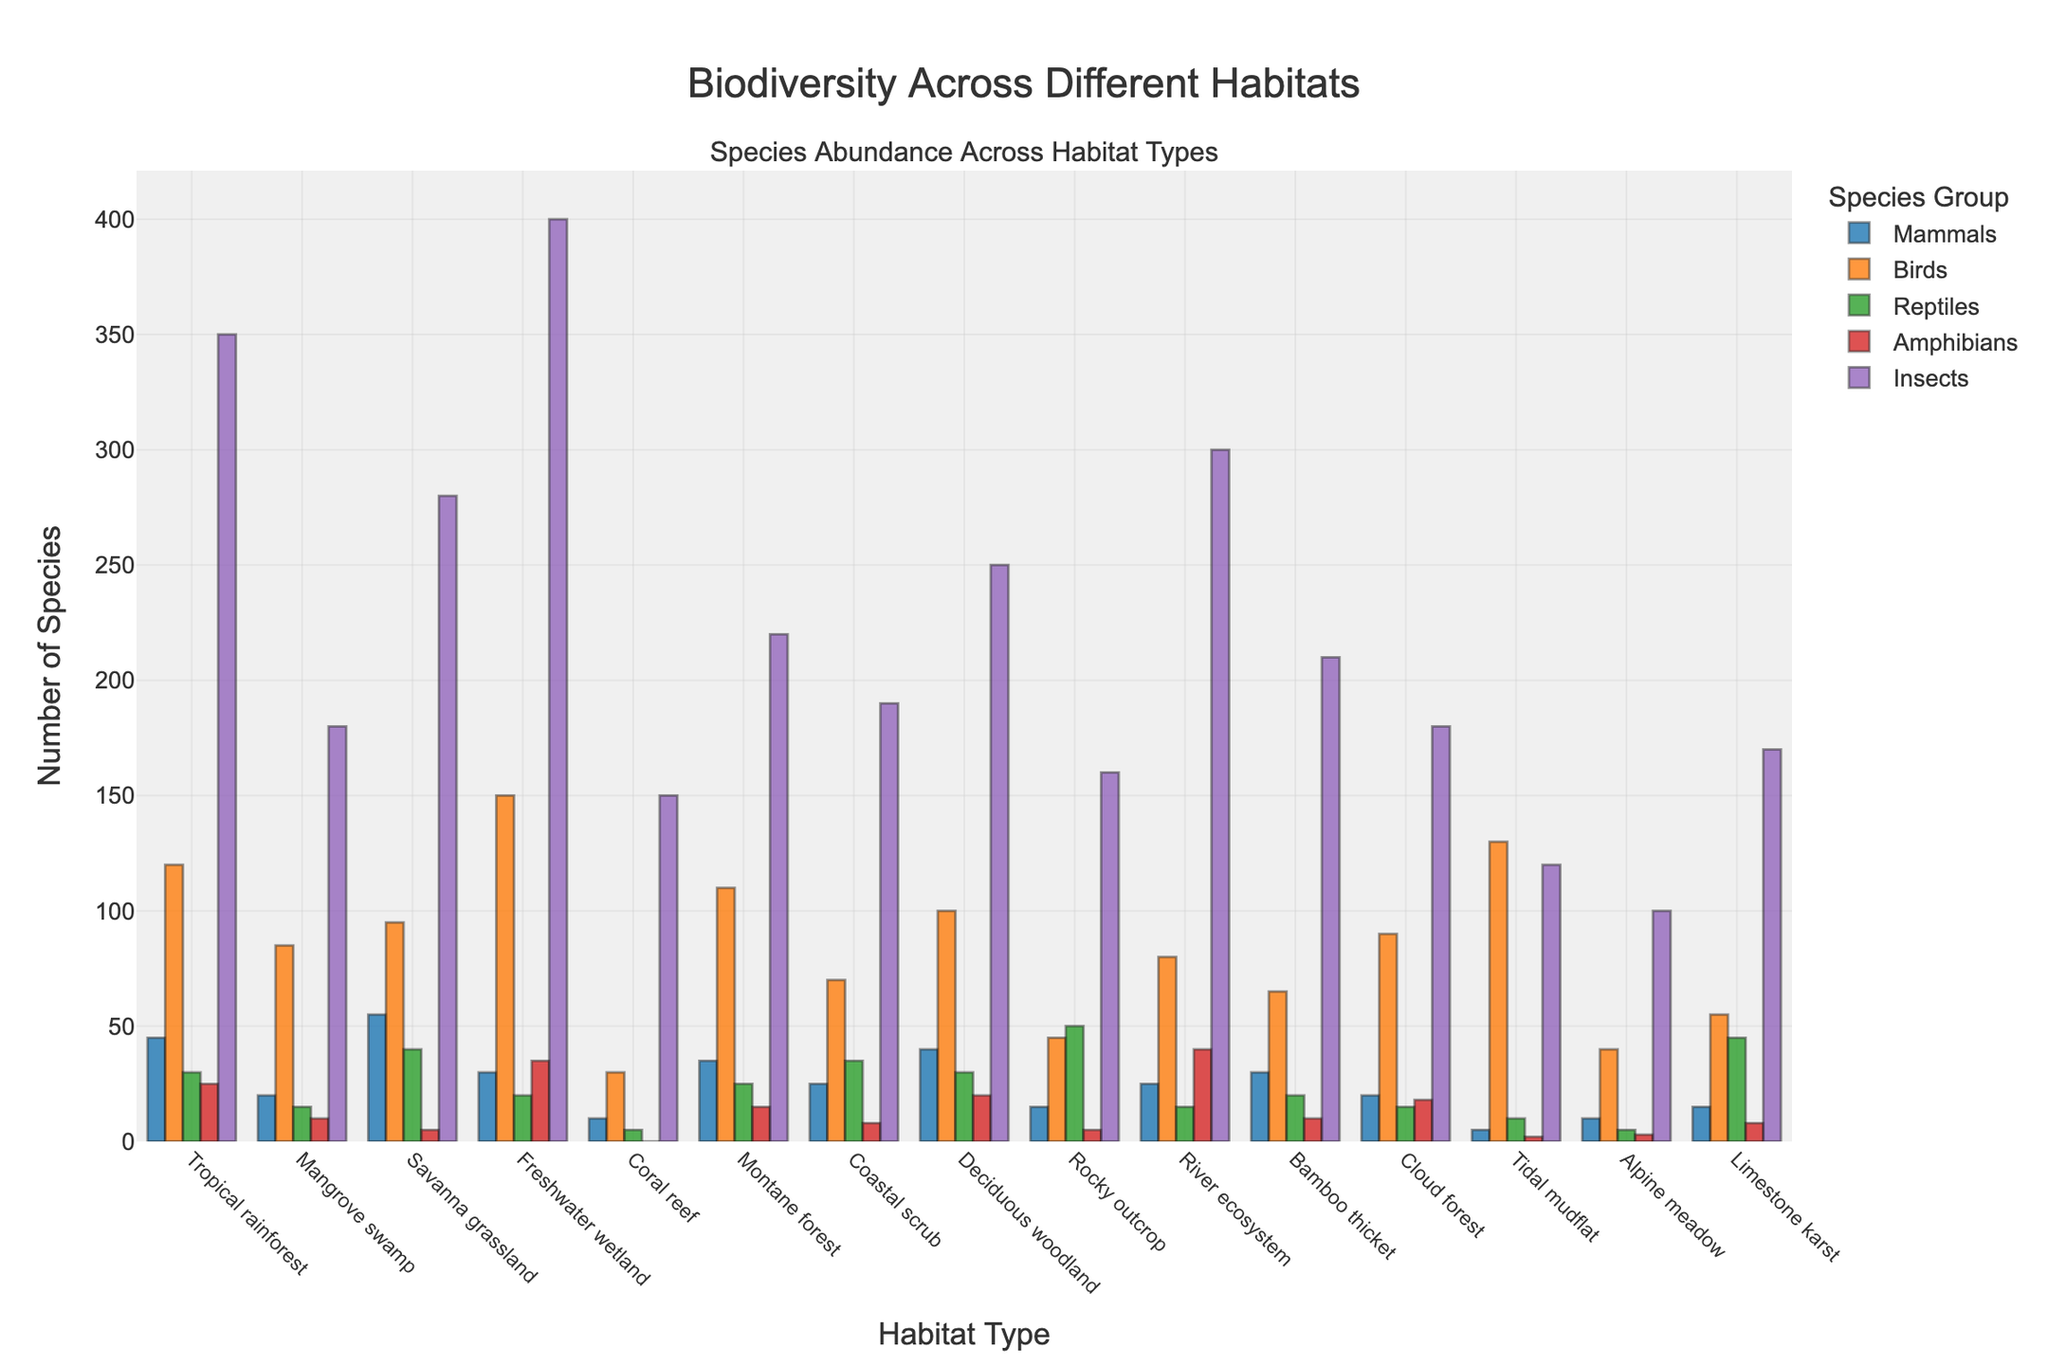Which habitat has the highest number of birds? To answer this question, scan the bar heights for birds across all habitats in the figure. The tallest bar corresponds to the habitat with the greatest number of birds, which is "Freshwater wetland" with 150 birds.
Answer: Freshwater wetland Which habitat has the least number of reptiles? Look at the bars representing reptiles in each habitat and identify the shortest. The shortest bar is associated with the "Alpine meadow" habitat, which has only 5 reptiles.
Answer: Alpine meadow How many mammals and birds are there in the Tropical rainforest combined? Find the bars representing mammals (45) and birds (120) in the "Tropical rainforest" habitat. Add these two values together: 45 + 120 = 165.
Answer: 165 Which habitat has a higher number of amphibians, Montane forest or Coastal scrub? Compare the heights of the bars representing amphibians in "Montane forest" (15) and "Coastal scrub" (8). Montane forest has a higher number.
Answer: Montane forest What is the total number of species recorded in the River ecosystem? For the "River ecosystem" habitat, sum the species counts across all groups: 25 (mammals) + 80 (birds) + 15 (reptiles) + 40 (amphibians) + 300 (insects) = 460.
Answer: 460 Which two habitats have the same number of amphibians? Visually inspect the bars for amphibians across all habitats. "Montane forest" and "Limestone karst" both have 15 amphibians.
Answer: Montane forest and Limestone karst What is the average number of insects across all habitats? Sum the insect counts for all habitats and divide by the number of habitats. Total insects count: 350 + 180 + 280 + 400 + 150 + 220 + 190 + 250 + 160 + 300 + 210 + 180 + 120 + 100 + 170 = 3660. Divide by the number of habitats (15): 3660 / 15 = 244.
Answer: 244 Which habitat has the second highest number of reptiles? Identify and rank the bars for reptiles in all habitats. The habitat with the second highest count after "Rocky outcrop" (50) is "Limestone karst", with 45 reptiles.
Answer: Limestone karst Which habitat shows a higher abundance of insects, Coastal scrub or Bamboo thicket? Compare the bar heights for insects in "Coastal scrub" (190) and "Bamboo thicket" (210). Bamboo thicket has a higher abundance.
Answer: Bamboo thicket What is the difference in the number of birds between Tropical rainforest and Tidal mudflat? Identify the birds bar heights for "Tropical rainforest" (120) and "Tidal mudflat" (130). Calculate the difference: 130 - 120 = 10.
Answer: 10 